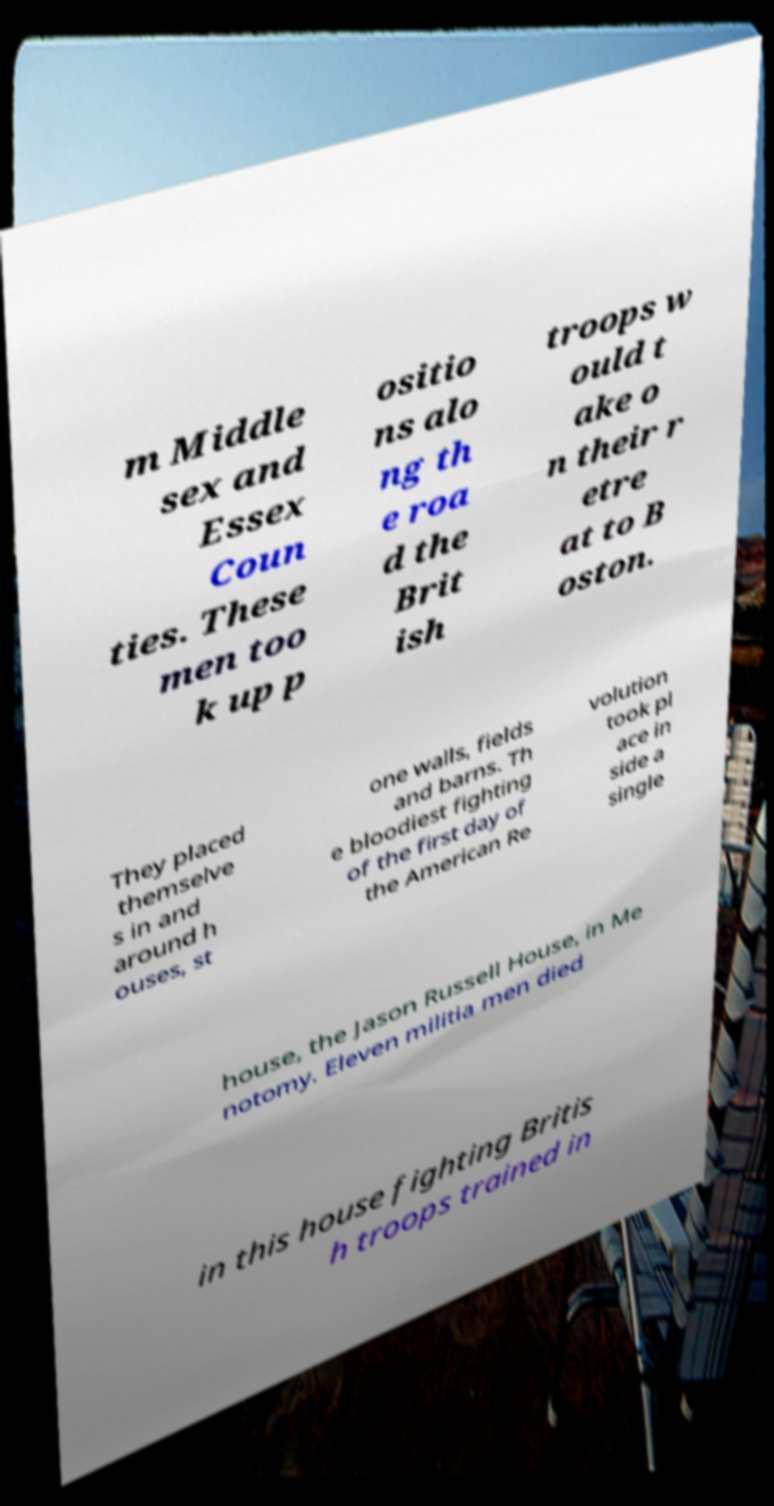Could you extract and type out the text from this image? m Middle sex and Essex Coun ties. These men too k up p ositio ns alo ng th e roa d the Brit ish troops w ould t ake o n their r etre at to B oston. They placed themselve s in and around h ouses, st one walls, fields and barns. Th e bloodiest fighting of the first day of the American Re volution took pl ace in side a single house, the Jason Russell House, in Me notomy. Eleven militia men died in this house fighting Britis h troops trained in 